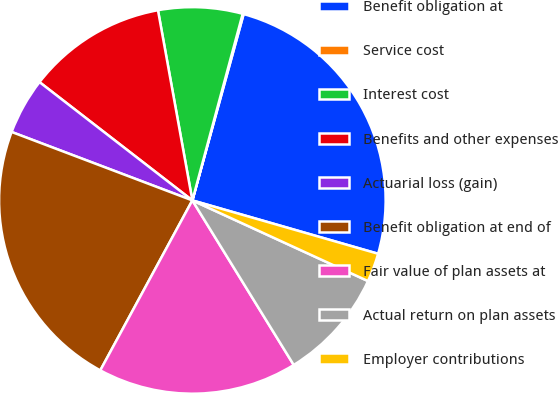<chart> <loc_0><loc_0><loc_500><loc_500><pie_chart><fcel>Benefit obligation at<fcel>Service cost<fcel>Interest cost<fcel>Benefits and other expenses<fcel>Actuarial loss (gain)<fcel>Benefit obligation at end of<fcel>Fair value of plan assets at<fcel>Actual return on plan assets<fcel>Employer contributions<nl><fcel>25.18%<fcel>0.08%<fcel>7.04%<fcel>11.67%<fcel>4.72%<fcel>22.86%<fcel>16.69%<fcel>9.36%<fcel>2.4%<nl></chart> 